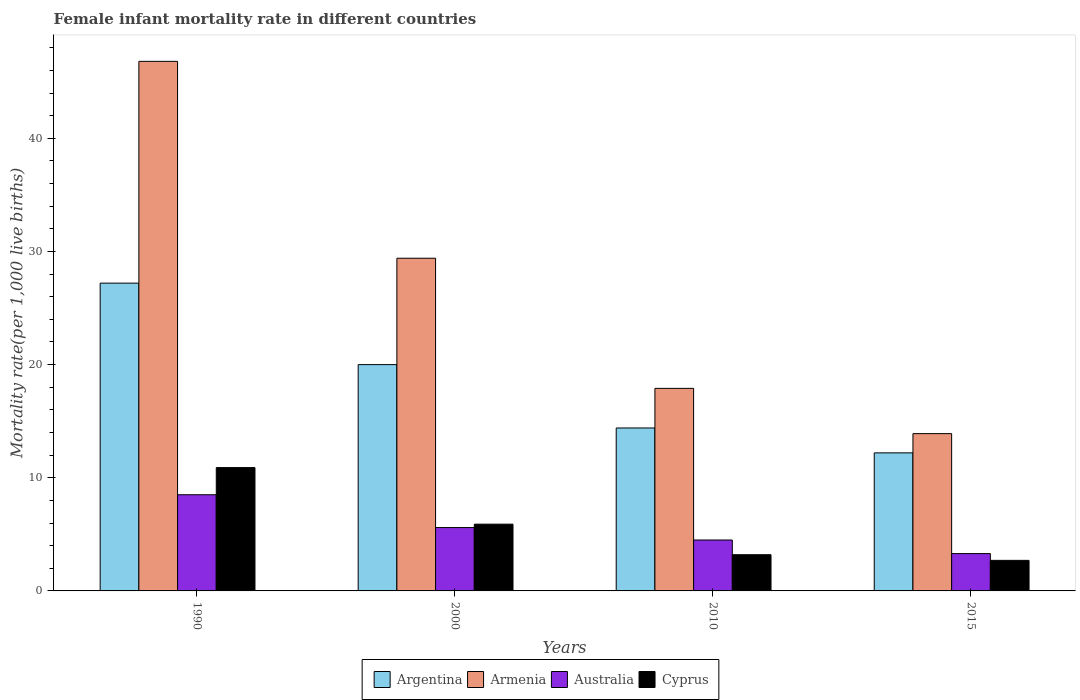How many different coloured bars are there?
Your answer should be very brief. 4. Are the number of bars on each tick of the X-axis equal?
Provide a short and direct response. Yes. How many bars are there on the 4th tick from the left?
Keep it short and to the point. 4. In how many cases, is the number of bars for a given year not equal to the number of legend labels?
Provide a short and direct response. 0. What is the female infant mortality rate in Argentina in 1990?
Keep it short and to the point. 27.2. Across all years, what is the maximum female infant mortality rate in Armenia?
Keep it short and to the point. 46.8. In which year was the female infant mortality rate in Argentina minimum?
Your answer should be very brief. 2015. What is the total female infant mortality rate in Cyprus in the graph?
Offer a very short reply. 22.7. What is the average female infant mortality rate in Argentina per year?
Offer a terse response. 18.45. In the year 2015, what is the difference between the female infant mortality rate in Australia and female infant mortality rate in Argentina?
Make the answer very short. -8.9. In how many years, is the female infant mortality rate in Australia greater than 36?
Ensure brevity in your answer.  0. What is the ratio of the female infant mortality rate in Argentina in 2010 to that in 2015?
Your response must be concise. 1.18. Is the female infant mortality rate in Australia in 1990 less than that in 2015?
Provide a succinct answer. No. Is the difference between the female infant mortality rate in Australia in 1990 and 2000 greater than the difference between the female infant mortality rate in Argentina in 1990 and 2000?
Provide a succinct answer. No. What is the difference between the highest and the second highest female infant mortality rate in Australia?
Keep it short and to the point. 2.9. In how many years, is the female infant mortality rate in Argentina greater than the average female infant mortality rate in Argentina taken over all years?
Keep it short and to the point. 2. What does the 4th bar from the right in 2000 represents?
Make the answer very short. Argentina. How many bars are there?
Ensure brevity in your answer.  16. Does the graph contain any zero values?
Your response must be concise. No. Where does the legend appear in the graph?
Your answer should be very brief. Bottom center. How are the legend labels stacked?
Offer a terse response. Horizontal. What is the title of the graph?
Provide a succinct answer. Female infant mortality rate in different countries. Does "Burkina Faso" appear as one of the legend labels in the graph?
Ensure brevity in your answer.  No. What is the label or title of the Y-axis?
Keep it short and to the point. Mortality rate(per 1,0 live births). What is the Mortality rate(per 1,000 live births) of Argentina in 1990?
Provide a short and direct response. 27.2. What is the Mortality rate(per 1,000 live births) of Armenia in 1990?
Offer a very short reply. 46.8. What is the Mortality rate(per 1,000 live births) in Australia in 1990?
Offer a very short reply. 8.5. What is the Mortality rate(per 1,000 live births) of Armenia in 2000?
Keep it short and to the point. 29.4. What is the Mortality rate(per 1,000 live births) of Cyprus in 2000?
Provide a short and direct response. 5.9. What is the Mortality rate(per 1,000 live births) of Argentina in 2010?
Offer a very short reply. 14.4. Across all years, what is the maximum Mortality rate(per 1,000 live births) in Argentina?
Give a very brief answer. 27.2. Across all years, what is the maximum Mortality rate(per 1,000 live births) in Armenia?
Offer a very short reply. 46.8. Across all years, what is the minimum Mortality rate(per 1,000 live births) of Australia?
Make the answer very short. 3.3. What is the total Mortality rate(per 1,000 live births) of Argentina in the graph?
Your answer should be compact. 73.8. What is the total Mortality rate(per 1,000 live births) of Armenia in the graph?
Provide a short and direct response. 108. What is the total Mortality rate(per 1,000 live births) of Australia in the graph?
Give a very brief answer. 21.9. What is the total Mortality rate(per 1,000 live births) of Cyprus in the graph?
Keep it short and to the point. 22.7. What is the difference between the Mortality rate(per 1,000 live births) of Australia in 1990 and that in 2000?
Your response must be concise. 2.9. What is the difference between the Mortality rate(per 1,000 live births) in Cyprus in 1990 and that in 2000?
Ensure brevity in your answer.  5. What is the difference between the Mortality rate(per 1,000 live births) in Argentina in 1990 and that in 2010?
Offer a very short reply. 12.8. What is the difference between the Mortality rate(per 1,000 live births) in Armenia in 1990 and that in 2010?
Keep it short and to the point. 28.9. What is the difference between the Mortality rate(per 1,000 live births) of Australia in 1990 and that in 2010?
Ensure brevity in your answer.  4. What is the difference between the Mortality rate(per 1,000 live births) of Armenia in 1990 and that in 2015?
Your answer should be compact. 32.9. What is the difference between the Mortality rate(per 1,000 live births) in Cyprus in 1990 and that in 2015?
Provide a short and direct response. 8.2. What is the difference between the Mortality rate(per 1,000 live births) of Argentina in 2000 and that in 2010?
Offer a very short reply. 5.6. What is the difference between the Mortality rate(per 1,000 live births) in Armenia in 2000 and that in 2010?
Keep it short and to the point. 11.5. What is the difference between the Mortality rate(per 1,000 live births) of Cyprus in 2000 and that in 2010?
Provide a succinct answer. 2.7. What is the difference between the Mortality rate(per 1,000 live births) of Armenia in 2000 and that in 2015?
Offer a very short reply. 15.5. What is the difference between the Mortality rate(per 1,000 live births) in Australia in 2000 and that in 2015?
Give a very brief answer. 2.3. What is the difference between the Mortality rate(per 1,000 live births) in Cyprus in 2000 and that in 2015?
Ensure brevity in your answer.  3.2. What is the difference between the Mortality rate(per 1,000 live births) of Armenia in 2010 and that in 2015?
Offer a terse response. 4. What is the difference between the Mortality rate(per 1,000 live births) in Cyprus in 2010 and that in 2015?
Your answer should be very brief. 0.5. What is the difference between the Mortality rate(per 1,000 live births) of Argentina in 1990 and the Mortality rate(per 1,000 live births) of Armenia in 2000?
Ensure brevity in your answer.  -2.2. What is the difference between the Mortality rate(per 1,000 live births) in Argentina in 1990 and the Mortality rate(per 1,000 live births) in Australia in 2000?
Provide a short and direct response. 21.6. What is the difference between the Mortality rate(per 1,000 live births) of Argentina in 1990 and the Mortality rate(per 1,000 live births) of Cyprus in 2000?
Provide a succinct answer. 21.3. What is the difference between the Mortality rate(per 1,000 live births) of Armenia in 1990 and the Mortality rate(per 1,000 live births) of Australia in 2000?
Offer a terse response. 41.2. What is the difference between the Mortality rate(per 1,000 live births) in Armenia in 1990 and the Mortality rate(per 1,000 live births) in Cyprus in 2000?
Ensure brevity in your answer.  40.9. What is the difference between the Mortality rate(per 1,000 live births) in Australia in 1990 and the Mortality rate(per 1,000 live births) in Cyprus in 2000?
Your response must be concise. 2.6. What is the difference between the Mortality rate(per 1,000 live births) in Argentina in 1990 and the Mortality rate(per 1,000 live births) in Armenia in 2010?
Make the answer very short. 9.3. What is the difference between the Mortality rate(per 1,000 live births) of Argentina in 1990 and the Mortality rate(per 1,000 live births) of Australia in 2010?
Make the answer very short. 22.7. What is the difference between the Mortality rate(per 1,000 live births) in Armenia in 1990 and the Mortality rate(per 1,000 live births) in Australia in 2010?
Offer a very short reply. 42.3. What is the difference between the Mortality rate(per 1,000 live births) in Armenia in 1990 and the Mortality rate(per 1,000 live births) in Cyprus in 2010?
Offer a terse response. 43.6. What is the difference between the Mortality rate(per 1,000 live births) in Australia in 1990 and the Mortality rate(per 1,000 live births) in Cyprus in 2010?
Provide a succinct answer. 5.3. What is the difference between the Mortality rate(per 1,000 live births) of Argentina in 1990 and the Mortality rate(per 1,000 live births) of Armenia in 2015?
Provide a succinct answer. 13.3. What is the difference between the Mortality rate(per 1,000 live births) of Argentina in 1990 and the Mortality rate(per 1,000 live births) of Australia in 2015?
Give a very brief answer. 23.9. What is the difference between the Mortality rate(per 1,000 live births) in Armenia in 1990 and the Mortality rate(per 1,000 live births) in Australia in 2015?
Ensure brevity in your answer.  43.5. What is the difference between the Mortality rate(per 1,000 live births) of Armenia in 1990 and the Mortality rate(per 1,000 live births) of Cyprus in 2015?
Provide a succinct answer. 44.1. What is the difference between the Mortality rate(per 1,000 live births) of Argentina in 2000 and the Mortality rate(per 1,000 live births) of Australia in 2010?
Your answer should be compact. 15.5. What is the difference between the Mortality rate(per 1,000 live births) in Armenia in 2000 and the Mortality rate(per 1,000 live births) in Australia in 2010?
Ensure brevity in your answer.  24.9. What is the difference between the Mortality rate(per 1,000 live births) of Armenia in 2000 and the Mortality rate(per 1,000 live births) of Cyprus in 2010?
Your answer should be compact. 26.2. What is the difference between the Mortality rate(per 1,000 live births) in Argentina in 2000 and the Mortality rate(per 1,000 live births) in Armenia in 2015?
Your answer should be very brief. 6.1. What is the difference between the Mortality rate(per 1,000 live births) of Argentina in 2000 and the Mortality rate(per 1,000 live births) of Australia in 2015?
Your response must be concise. 16.7. What is the difference between the Mortality rate(per 1,000 live births) in Armenia in 2000 and the Mortality rate(per 1,000 live births) in Australia in 2015?
Provide a succinct answer. 26.1. What is the difference between the Mortality rate(per 1,000 live births) of Armenia in 2000 and the Mortality rate(per 1,000 live births) of Cyprus in 2015?
Offer a very short reply. 26.7. What is the difference between the Mortality rate(per 1,000 live births) of Argentina in 2010 and the Mortality rate(per 1,000 live births) of Australia in 2015?
Offer a very short reply. 11.1. What is the difference between the Mortality rate(per 1,000 live births) of Argentina in 2010 and the Mortality rate(per 1,000 live births) of Cyprus in 2015?
Keep it short and to the point. 11.7. What is the average Mortality rate(per 1,000 live births) of Argentina per year?
Make the answer very short. 18.45. What is the average Mortality rate(per 1,000 live births) in Armenia per year?
Your answer should be very brief. 27. What is the average Mortality rate(per 1,000 live births) of Australia per year?
Your response must be concise. 5.47. What is the average Mortality rate(per 1,000 live births) in Cyprus per year?
Your answer should be compact. 5.67. In the year 1990, what is the difference between the Mortality rate(per 1,000 live births) of Argentina and Mortality rate(per 1,000 live births) of Armenia?
Make the answer very short. -19.6. In the year 1990, what is the difference between the Mortality rate(per 1,000 live births) in Argentina and Mortality rate(per 1,000 live births) in Australia?
Ensure brevity in your answer.  18.7. In the year 1990, what is the difference between the Mortality rate(per 1,000 live births) in Armenia and Mortality rate(per 1,000 live births) in Australia?
Make the answer very short. 38.3. In the year 1990, what is the difference between the Mortality rate(per 1,000 live births) in Armenia and Mortality rate(per 1,000 live births) in Cyprus?
Provide a succinct answer. 35.9. In the year 1990, what is the difference between the Mortality rate(per 1,000 live births) in Australia and Mortality rate(per 1,000 live births) in Cyprus?
Make the answer very short. -2.4. In the year 2000, what is the difference between the Mortality rate(per 1,000 live births) in Argentina and Mortality rate(per 1,000 live births) in Armenia?
Give a very brief answer. -9.4. In the year 2000, what is the difference between the Mortality rate(per 1,000 live births) of Argentina and Mortality rate(per 1,000 live births) of Australia?
Your response must be concise. 14.4. In the year 2000, what is the difference between the Mortality rate(per 1,000 live births) of Armenia and Mortality rate(per 1,000 live births) of Australia?
Your answer should be compact. 23.8. In the year 2010, what is the difference between the Mortality rate(per 1,000 live births) in Argentina and Mortality rate(per 1,000 live births) in Armenia?
Provide a succinct answer. -3.5. In the year 2010, what is the difference between the Mortality rate(per 1,000 live births) of Argentina and Mortality rate(per 1,000 live births) of Australia?
Provide a succinct answer. 9.9. In the year 2010, what is the difference between the Mortality rate(per 1,000 live births) of Argentina and Mortality rate(per 1,000 live births) of Cyprus?
Provide a short and direct response. 11.2. In the year 2010, what is the difference between the Mortality rate(per 1,000 live births) of Armenia and Mortality rate(per 1,000 live births) of Australia?
Your answer should be compact. 13.4. In the year 2015, what is the difference between the Mortality rate(per 1,000 live births) of Argentina and Mortality rate(per 1,000 live births) of Armenia?
Your response must be concise. -1.7. In the year 2015, what is the difference between the Mortality rate(per 1,000 live births) of Argentina and Mortality rate(per 1,000 live births) of Australia?
Your response must be concise. 8.9. In the year 2015, what is the difference between the Mortality rate(per 1,000 live births) of Armenia and Mortality rate(per 1,000 live births) of Cyprus?
Your answer should be very brief. 11.2. In the year 2015, what is the difference between the Mortality rate(per 1,000 live births) of Australia and Mortality rate(per 1,000 live births) of Cyprus?
Keep it short and to the point. 0.6. What is the ratio of the Mortality rate(per 1,000 live births) of Argentina in 1990 to that in 2000?
Make the answer very short. 1.36. What is the ratio of the Mortality rate(per 1,000 live births) of Armenia in 1990 to that in 2000?
Your response must be concise. 1.59. What is the ratio of the Mortality rate(per 1,000 live births) of Australia in 1990 to that in 2000?
Make the answer very short. 1.52. What is the ratio of the Mortality rate(per 1,000 live births) of Cyprus in 1990 to that in 2000?
Ensure brevity in your answer.  1.85. What is the ratio of the Mortality rate(per 1,000 live births) in Argentina in 1990 to that in 2010?
Keep it short and to the point. 1.89. What is the ratio of the Mortality rate(per 1,000 live births) of Armenia in 1990 to that in 2010?
Give a very brief answer. 2.61. What is the ratio of the Mortality rate(per 1,000 live births) in Australia in 1990 to that in 2010?
Keep it short and to the point. 1.89. What is the ratio of the Mortality rate(per 1,000 live births) of Cyprus in 1990 to that in 2010?
Offer a very short reply. 3.41. What is the ratio of the Mortality rate(per 1,000 live births) of Argentina in 1990 to that in 2015?
Keep it short and to the point. 2.23. What is the ratio of the Mortality rate(per 1,000 live births) of Armenia in 1990 to that in 2015?
Your answer should be compact. 3.37. What is the ratio of the Mortality rate(per 1,000 live births) in Australia in 1990 to that in 2015?
Your response must be concise. 2.58. What is the ratio of the Mortality rate(per 1,000 live births) of Cyprus in 1990 to that in 2015?
Provide a succinct answer. 4.04. What is the ratio of the Mortality rate(per 1,000 live births) of Argentina in 2000 to that in 2010?
Keep it short and to the point. 1.39. What is the ratio of the Mortality rate(per 1,000 live births) of Armenia in 2000 to that in 2010?
Ensure brevity in your answer.  1.64. What is the ratio of the Mortality rate(per 1,000 live births) in Australia in 2000 to that in 2010?
Make the answer very short. 1.24. What is the ratio of the Mortality rate(per 1,000 live births) in Cyprus in 2000 to that in 2010?
Keep it short and to the point. 1.84. What is the ratio of the Mortality rate(per 1,000 live births) in Argentina in 2000 to that in 2015?
Make the answer very short. 1.64. What is the ratio of the Mortality rate(per 1,000 live births) of Armenia in 2000 to that in 2015?
Provide a short and direct response. 2.12. What is the ratio of the Mortality rate(per 1,000 live births) of Australia in 2000 to that in 2015?
Your answer should be compact. 1.7. What is the ratio of the Mortality rate(per 1,000 live births) in Cyprus in 2000 to that in 2015?
Give a very brief answer. 2.19. What is the ratio of the Mortality rate(per 1,000 live births) in Argentina in 2010 to that in 2015?
Keep it short and to the point. 1.18. What is the ratio of the Mortality rate(per 1,000 live births) in Armenia in 2010 to that in 2015?
Keep it short and to the point. 1.29. What is the ratio of the Mortality rate(per 1,000 live births) in Australia in 2010 to that in 2015?
Make the answer very short. 1.36. What is the ratio of the Mortality rate(per 1,000 live births) of Cyprus in 2010 to that in 2015?
Your answer should be compact. 1.19. What is the difference between the highest and the second highest Mortality rate(per 1,000 live births) in Armenia?
Your response must be concise. 17.4. What is the difference between the highest and the lowest Mortality rate(per 1,000 live births) in Armenia?
Your answer should be compact. 32.9. What is the difference between the highest and the lowest Mortality rate(per 1,000 live births) of Australia?
Your answer should be very brief. 5.2. 